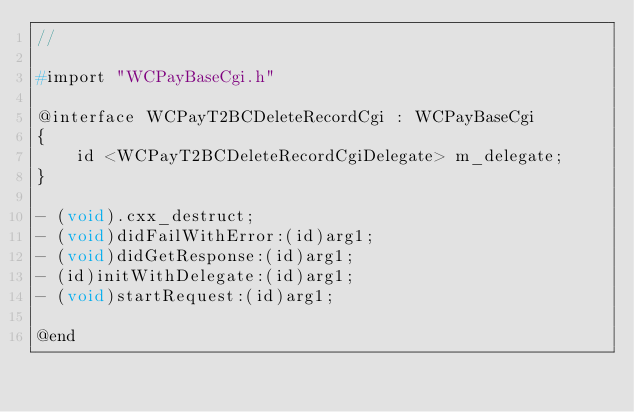<code> <loc_0><loc_0><loc_500><loc_500><_C_>//

#import "WCPayBaseCgi.h"

@interface WCPayT2BCDeleteRecordCgi : WCPayBaseCgi
{
    id <WCPayT2BCDeleteRecordCgiDelegate> m_delegate;
}

- (void).cxx_destruct;
- (void)didFailWithError:(id)arg1;
- (void)didGetResponse:(id)arg1;
- (id)initWithDelegate:(id)arg1;
- (void)startRequest:(id)arg1;

@end

</code> 